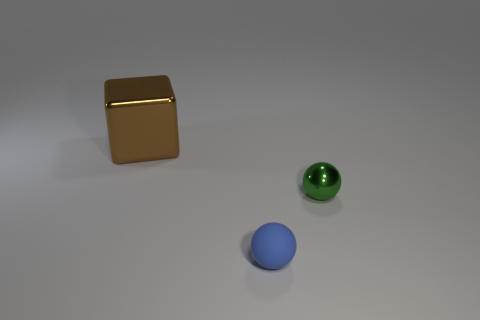Add 2 blue rubber balls. How many objects exist? 5 Subtract all red cylinders. How many green cubes are left? 0 Subtract 1 cubes. How many cubes are left? 0 Subtract all small blocks. Subtract all brown cubes. How many objects are left? 2 Add 3 green shiny objects. How many green shiny objects are left? 4 Add 3 metallic things. How many metallic things exist? 5 Subtract 0 yellow cylinders. How many objects are left? 3 Subtract all spheres. How many objects are left? 1 Subtract all gray spheres. Subtract all purple blocks. How many spheres are left? 2 